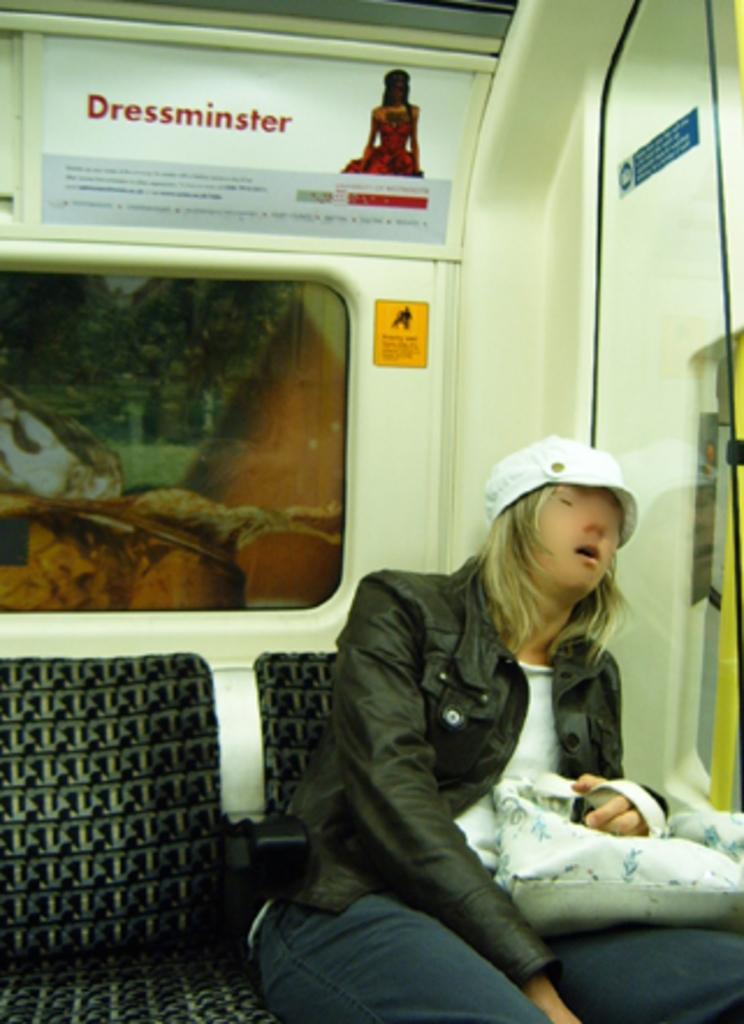Could you give a brief overview of what you see in this image? As we can see in the image there is a vehicle. In vehicle there is banner, a woman wearing black color jacket, white color hat and holding handbag. 